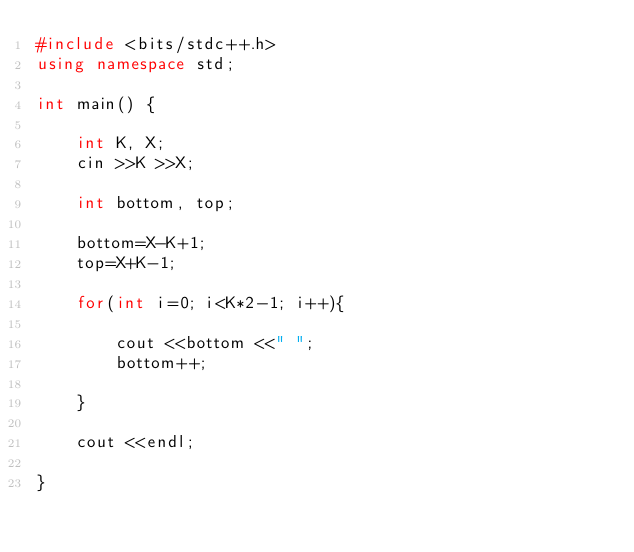<code> <loc_0><loc_0><loc_500><loc_500><_C++_>#include <bits/stdc++.h>
using namespace std;

int main() {
  
	int K, X;
	cin >>K >>X;
	
	int bottom, top;
	
	bottom=X-K+1;
	top=X+K-1;
	
	for(int i=0; i<K*2-1; i++){
		
		cout <<bottom <<" ";
		bottom++;
		
	}
	
	cout <<endl;
	
}</code> 